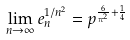Convert formula to latex. <formula><loc_0><loc_0><loc_500><loc_500>\lim _ { n \rightarrow \infty } e _ { n } ^ { 1 / n ^ { 2 } } = p ^ { \frac { 6 } { \pi ^ { 2 } } + \frac { 1 } { 4 } }</formula> 